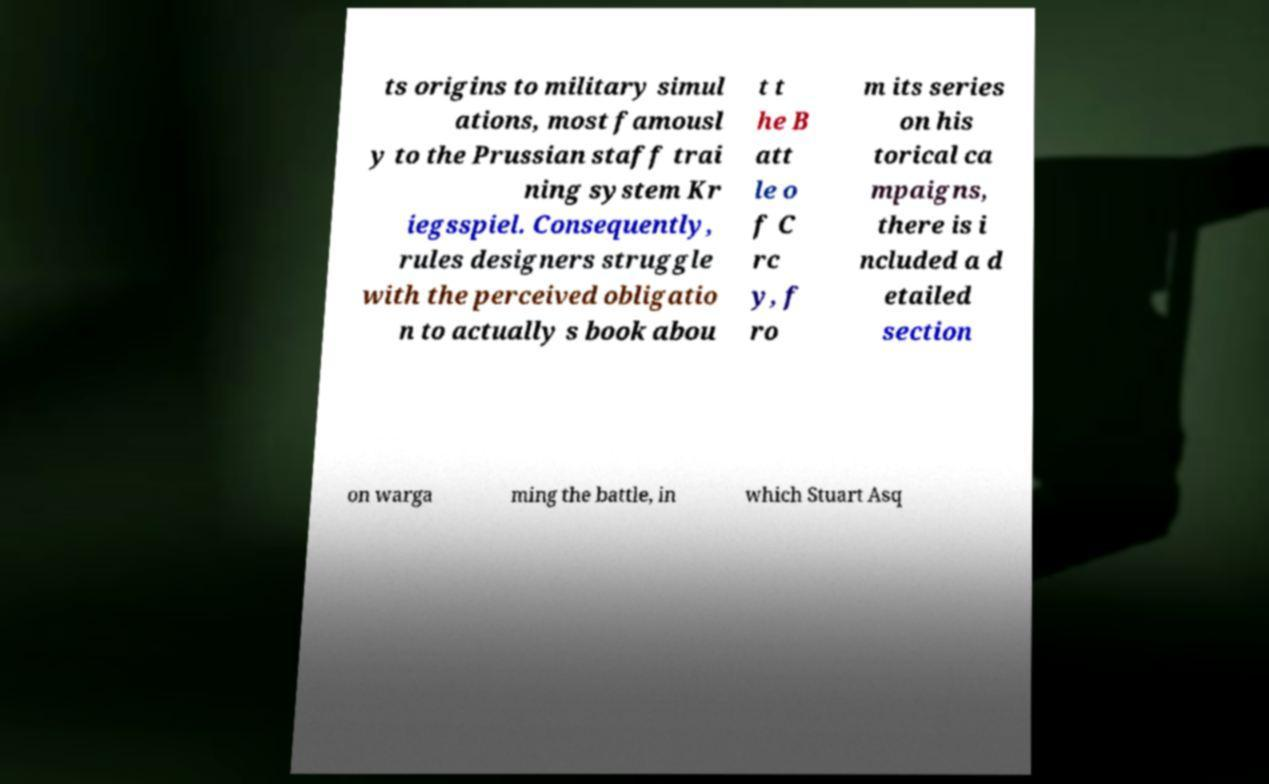I need the written content from this picture converted into text. Can you do that? ts origins to military simul ations, most famousl y to the Prussian staff trai ning system Kr iegsspiel. Consequently, rules designers struggle with the perceived obligatio n to actually s book abou t t he B att le o f C rc y, f ro m its series on his torical ca mpaigns, there is i ncluded a d etailed section on warga ming the battle, in which Stuart Asq 